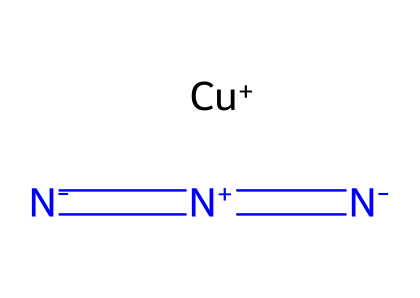What is the main element present in copper(I) azide? The chemical structure contains a copper atom indicated by the symbol "Cu" in the SMILES representation, making it the main element.
Answer: copper How many nitrogen atoms are in copper(I) azide? The structure has three nitrogen atoms represented by the "N" symbols in the SMILES notation, thus there are three nitrogen atoms.
Answer: three What is the oxidation state of copper in copper(I) azide? The "Cu+" notation indicates that the copper is in the +1 oxidation state, which is typical for copper in this specific azide compound.
Answer: +1 What type of bonds exist between the nitrogen atoms in copper(I) azide? The SMILES representation shows “=”, which signifies double bonds between the nitrogen atoms, specifically indicating nitrogen-nitrogen bonding.
Answer: double bonds What property makes copper(I) azide a primary explosive? The molecular structure shows a high proportion of nitrogen atoms with a unique arrangement that contributes to a high energy release upon decomposition, defining its explosive nature.
Answer: high energy release What functional group is present in copper(I) azide? The “-N=N=N” sequence indicates the presence of the azide functional group characteristic of azides, which is crucial for its reactivity and explosive properties.
Answer: azide group What characteristic is indicated by "Cu+" in this azide? The "Cu+" in the SMILES denotes that copper is in a monopositive state, a feature significant for the reactivity and role of the metal in the compound’s overall stability and explosive capacity.
Answer: mono-positive state 